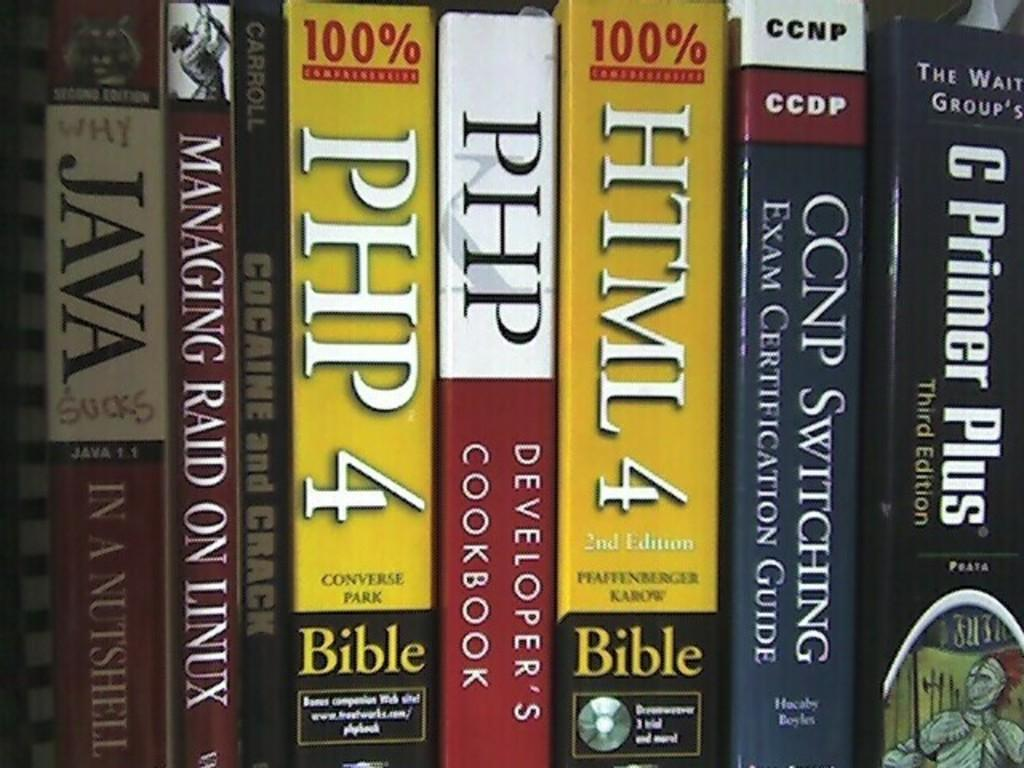Provide a one-sentence caption for the provided image. Books placed on a shelf with "HTML 4" being in the middle. 